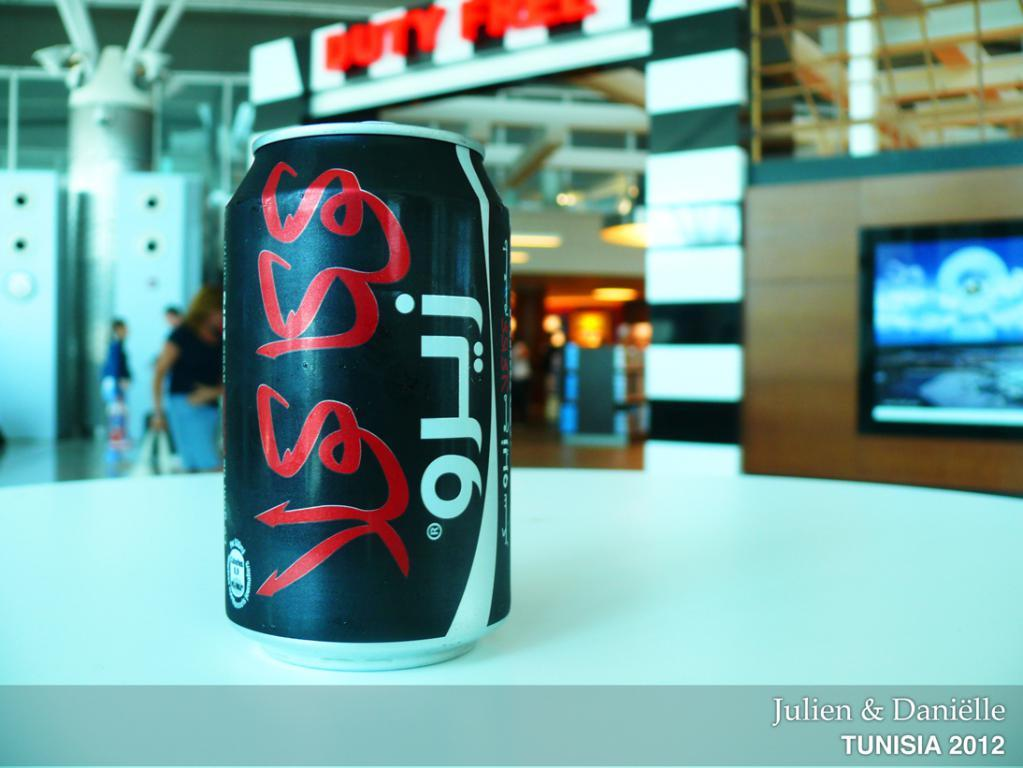<image>
Provide a brief description of the given image. A can of soda with writing other than English in a photo taken in 2012 in Tunisia. 